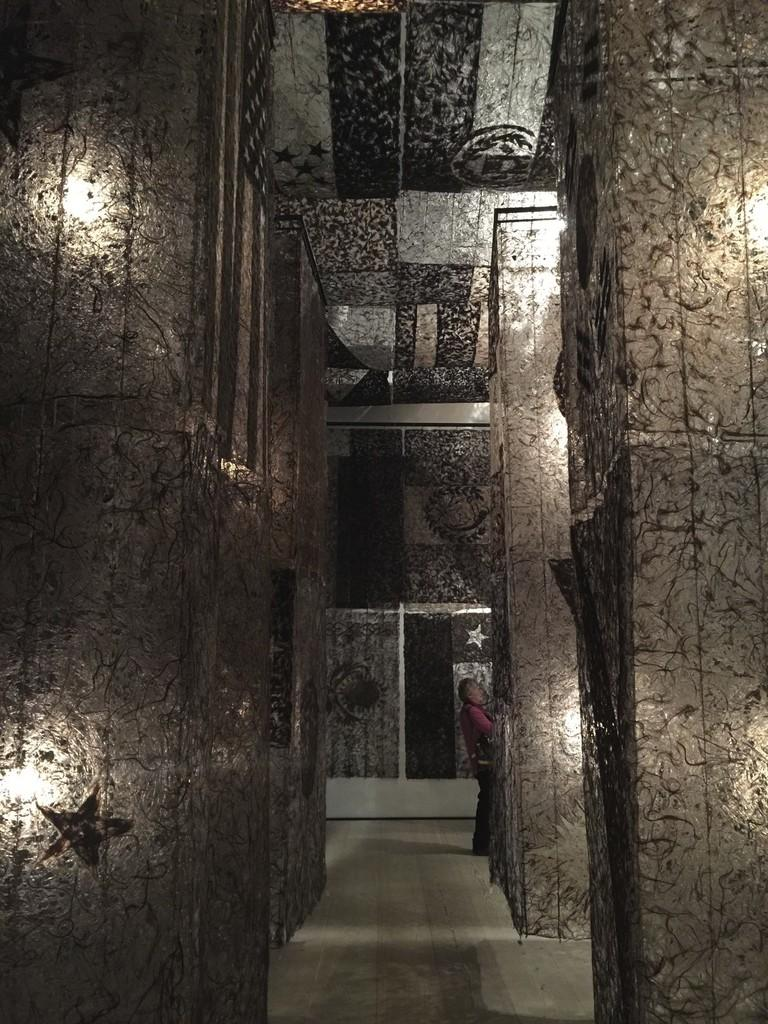What type of window is present in the image? There is a glass window in the image. Does the window have any unique features? Yes, the window has a design on it. What can be seen on the window's surface? There is a reflection visible on the window. How would you describe the lighting in the image? Both the left and right sides of the image are light. Can you see a woman holding a cup in the reflection on the window? There is no woman or cup present in the image or its reflection. 